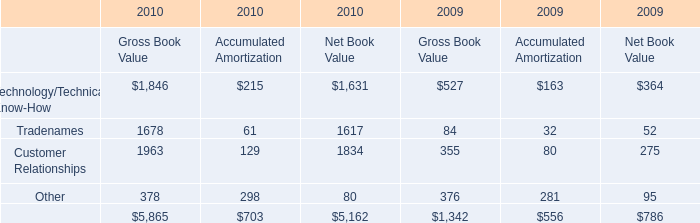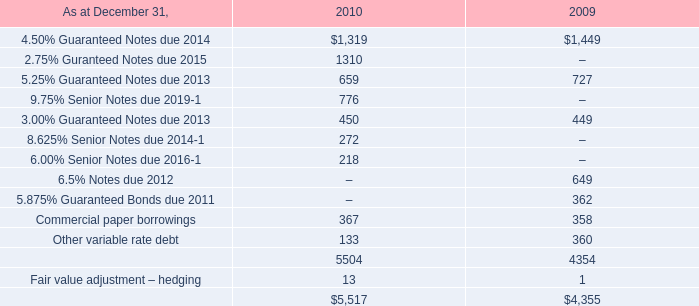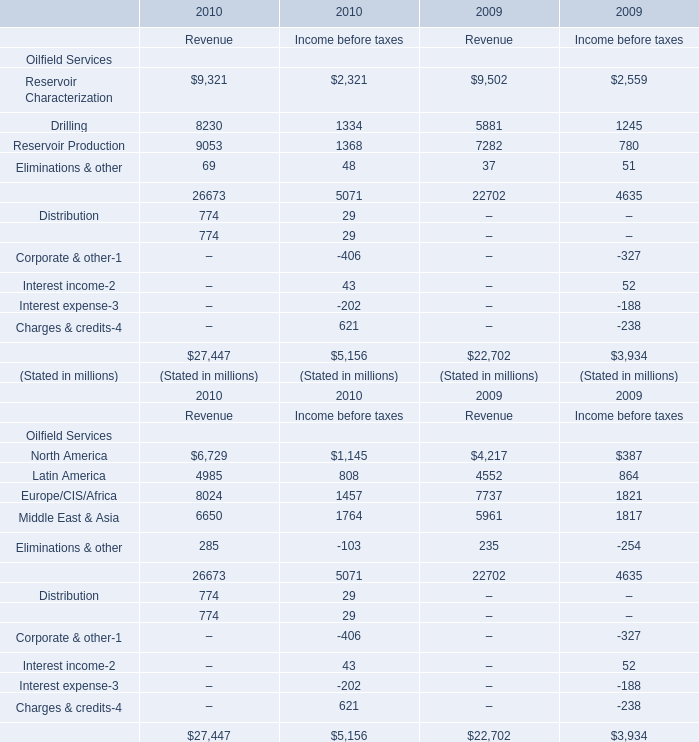What do all Oilfield Service sum up without those Oilfield Service smaller than 9000, in 2010 of revenue? (in million) 
Computations: (8230 + 69)
Answer: 8299.0. 